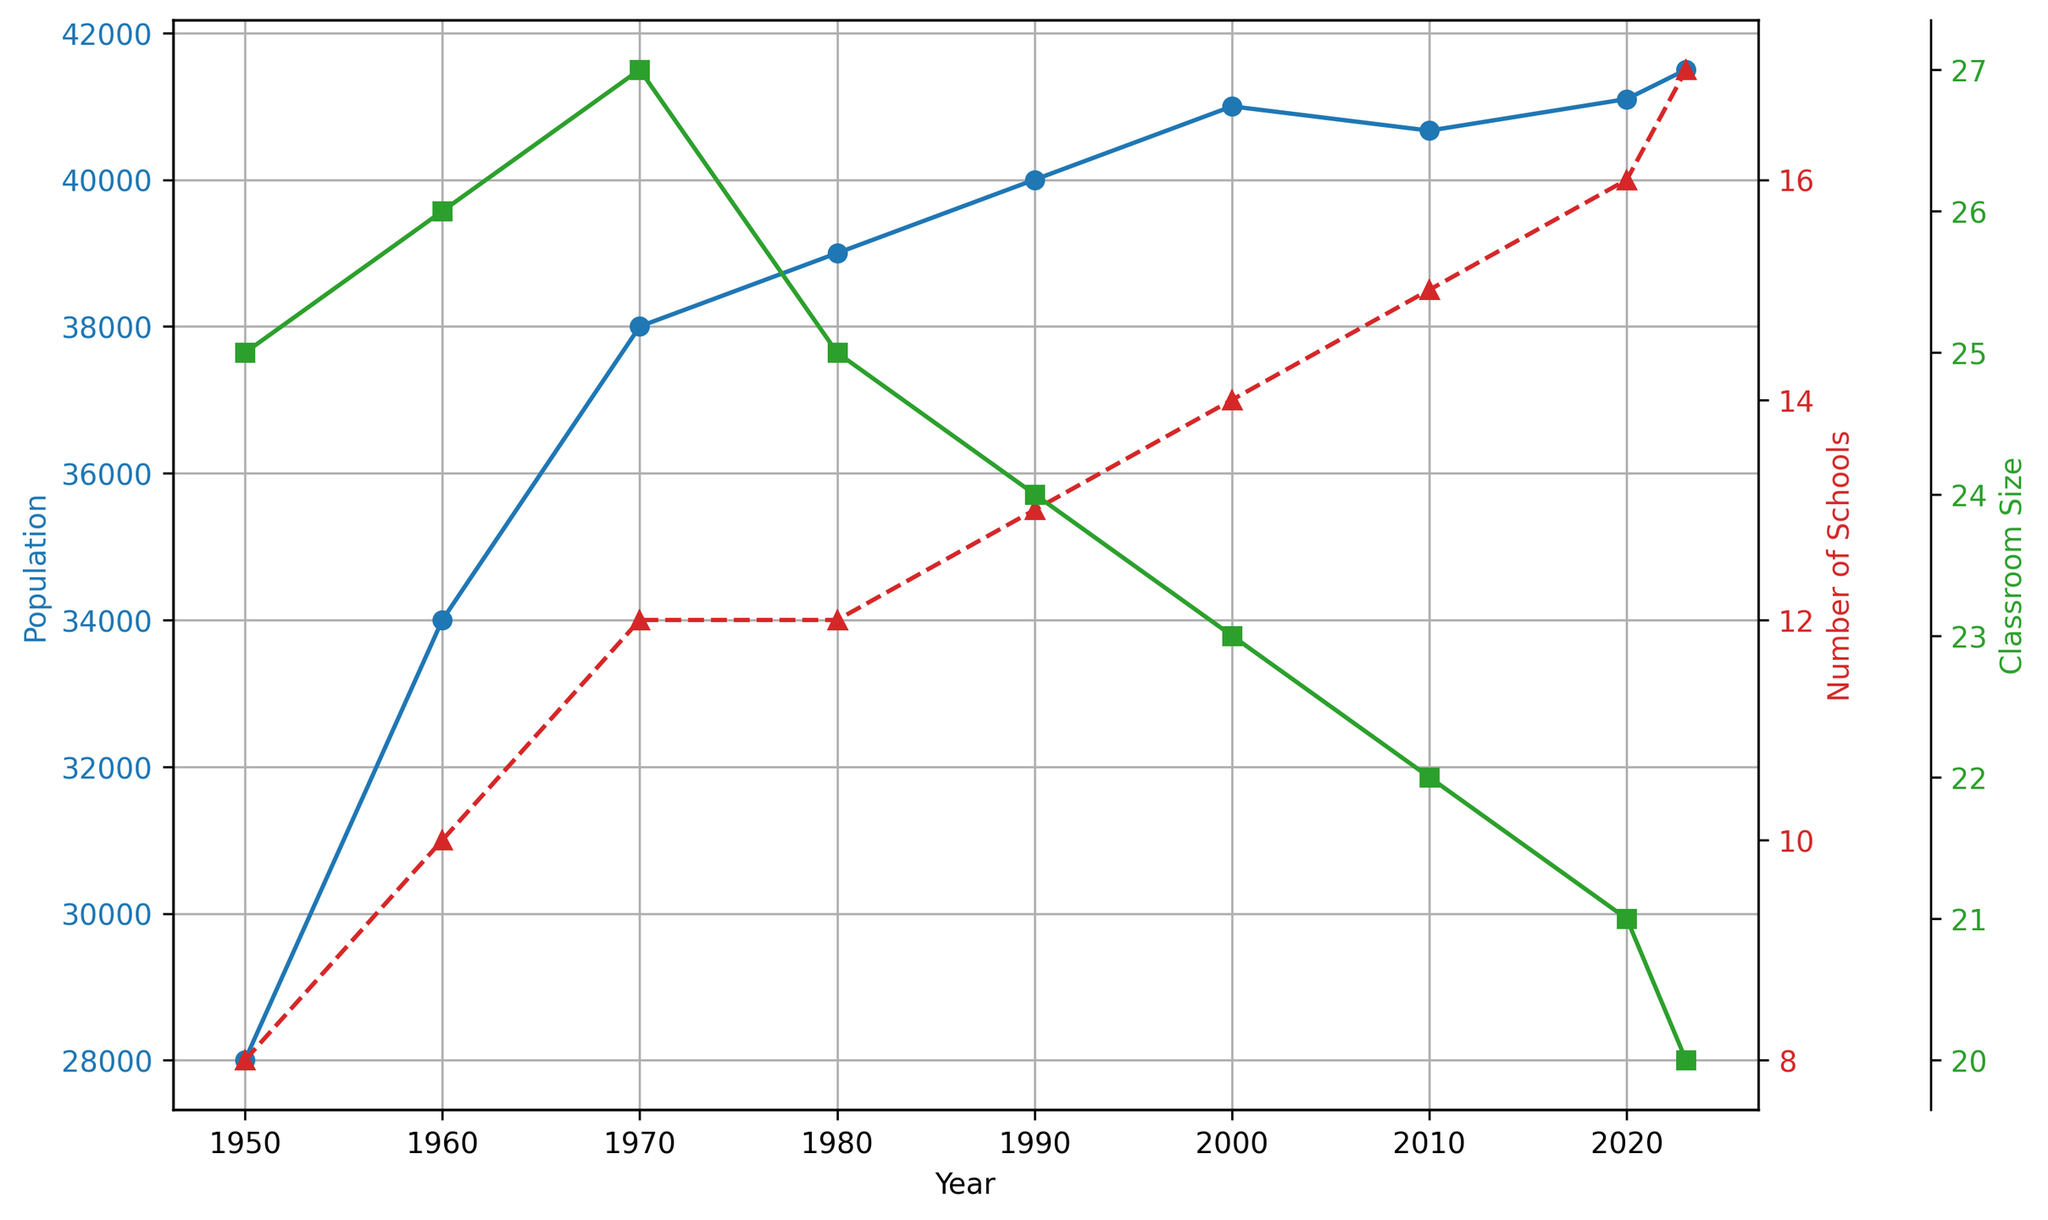What is the overall trend of the population from 1950 to 2023? The overall trend in the population can be observed from the blue plot, which shows a general increase from 28,000 in 1950 to about 41,500 in 2023.
Answer: Increasing In what year did the number of schools equal 10? The number of schools can be identified by the red plot with triangle markers. The plot shows that the number of schools reached 10 in 1960.
Answer: 1960 How did the classroom size change between 2000 and 2020? By observing the green plot with square markers, the classroom size decreased from 23 in 2000 to 21 in 2020.
Answer: Decreased In which year did Montclair have the highest population? By identifying the peak in the blue plot, the highest population appears in 2023 with about 41,500 people.
Answer: 2023 What was the average classroom size in the years 1980, 1990, and 2000? First, find the classroom sizes for the given years: 1980 (25), 1990 (24), 2000 (23). Then, calculate the average: (25 + 24 + 23) / 3 = 24.
Answer: 24 When was the smallest classroom size recorded and what was it? The green plot displays the classroom sizes, with the smallest size of 20 observed in 2023.
Answer: 2023, 20 During which decade did the number of schools see the largest increase? By examining the red plot for decade-to-decade changes, the largest increase occurs from 2000 (14 schools) to 2010 (15 schools), and then a bigger step from 2010 (15 schools) to 2020 (16 schools).
Answer: 2010-2020 Compare the population and number of schools in 1970 and 1980. Which increased more significantly? In 1970, the population was 38,000 and the number of schools was 12. In 1980, the population was 39,000 and the number of schools remained 12. Thus, the population increased more noticeably by 1,000 people, while the number of schools didn't increase.
Answer: Population How does the trend in the number of schools compare with the trend in classroom size from 1950 to 2023? The red plot shows an increasing trend in the number of schools, while the green plot shows a decreasing trend in classroom size over the same period.
Answer: Number of Schools: Increasing, Classroom Size: Decreasing Calculate the percentage change in population from 1960 to 2023. Population in 1960: 34,000. Population in 2023: 41,500. Percentage change = ((41,500 - 34,000) / 34,000) * 100 ≈ 22.06%.
Answer: 22.06% 